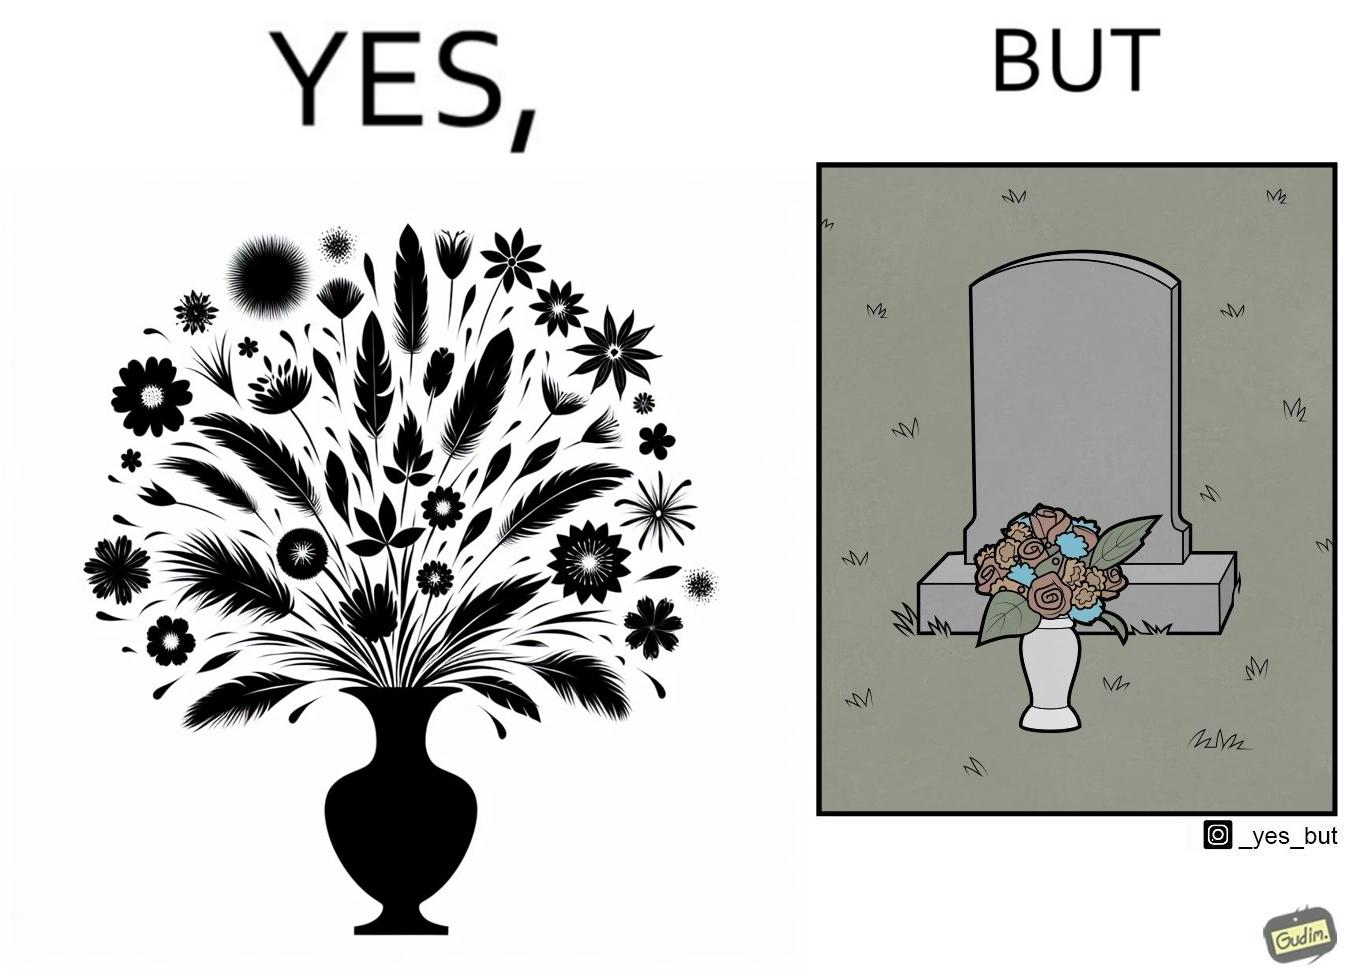Would you classify this image as satirical? Yes, this image is satirical. 